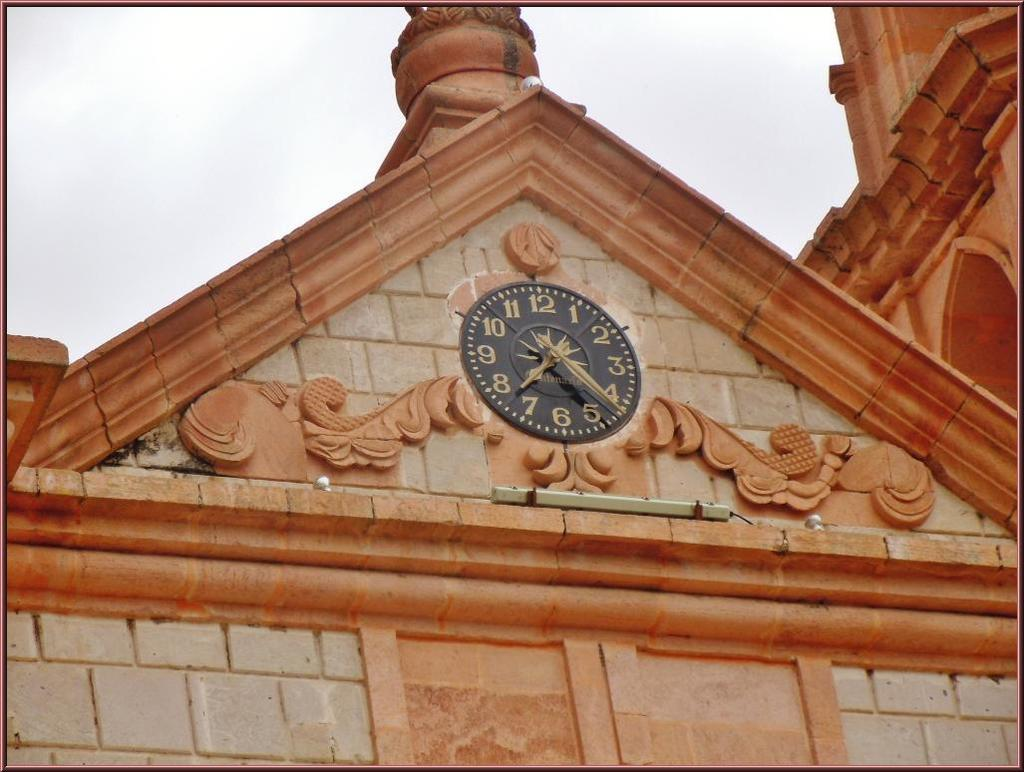<image>
Offer a succinct explanation of the picture presented. A red brown building with a clock on the front with the time at 7:25. 